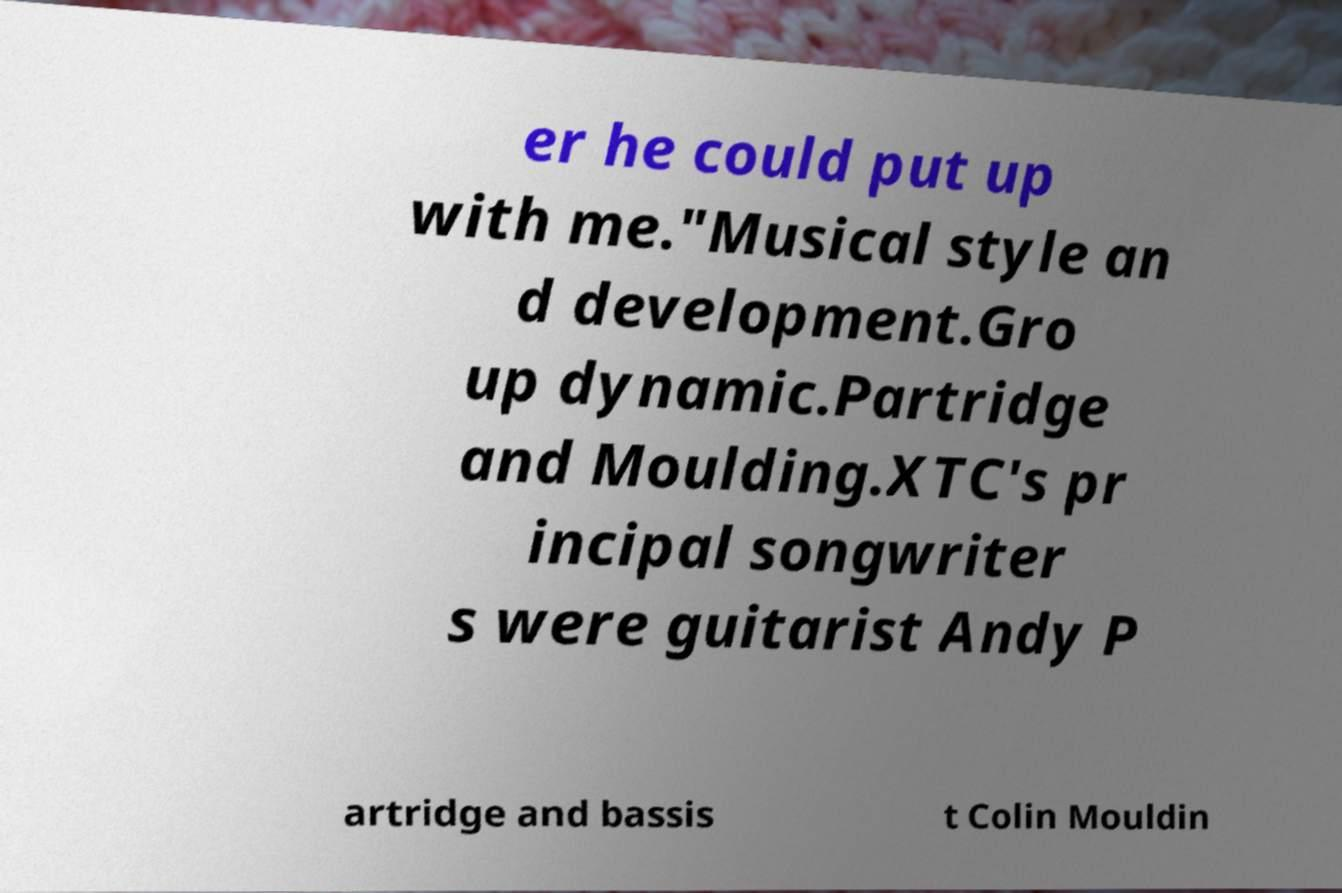Please identify and transcribe the text found in this image. er he could put up with me."Musical style an d development.Gro up dynamic.Partridge and Moulding.XTC's pr incipal songwriter s were guitarist Andy P artridge and bassis t Colin Mouldin 